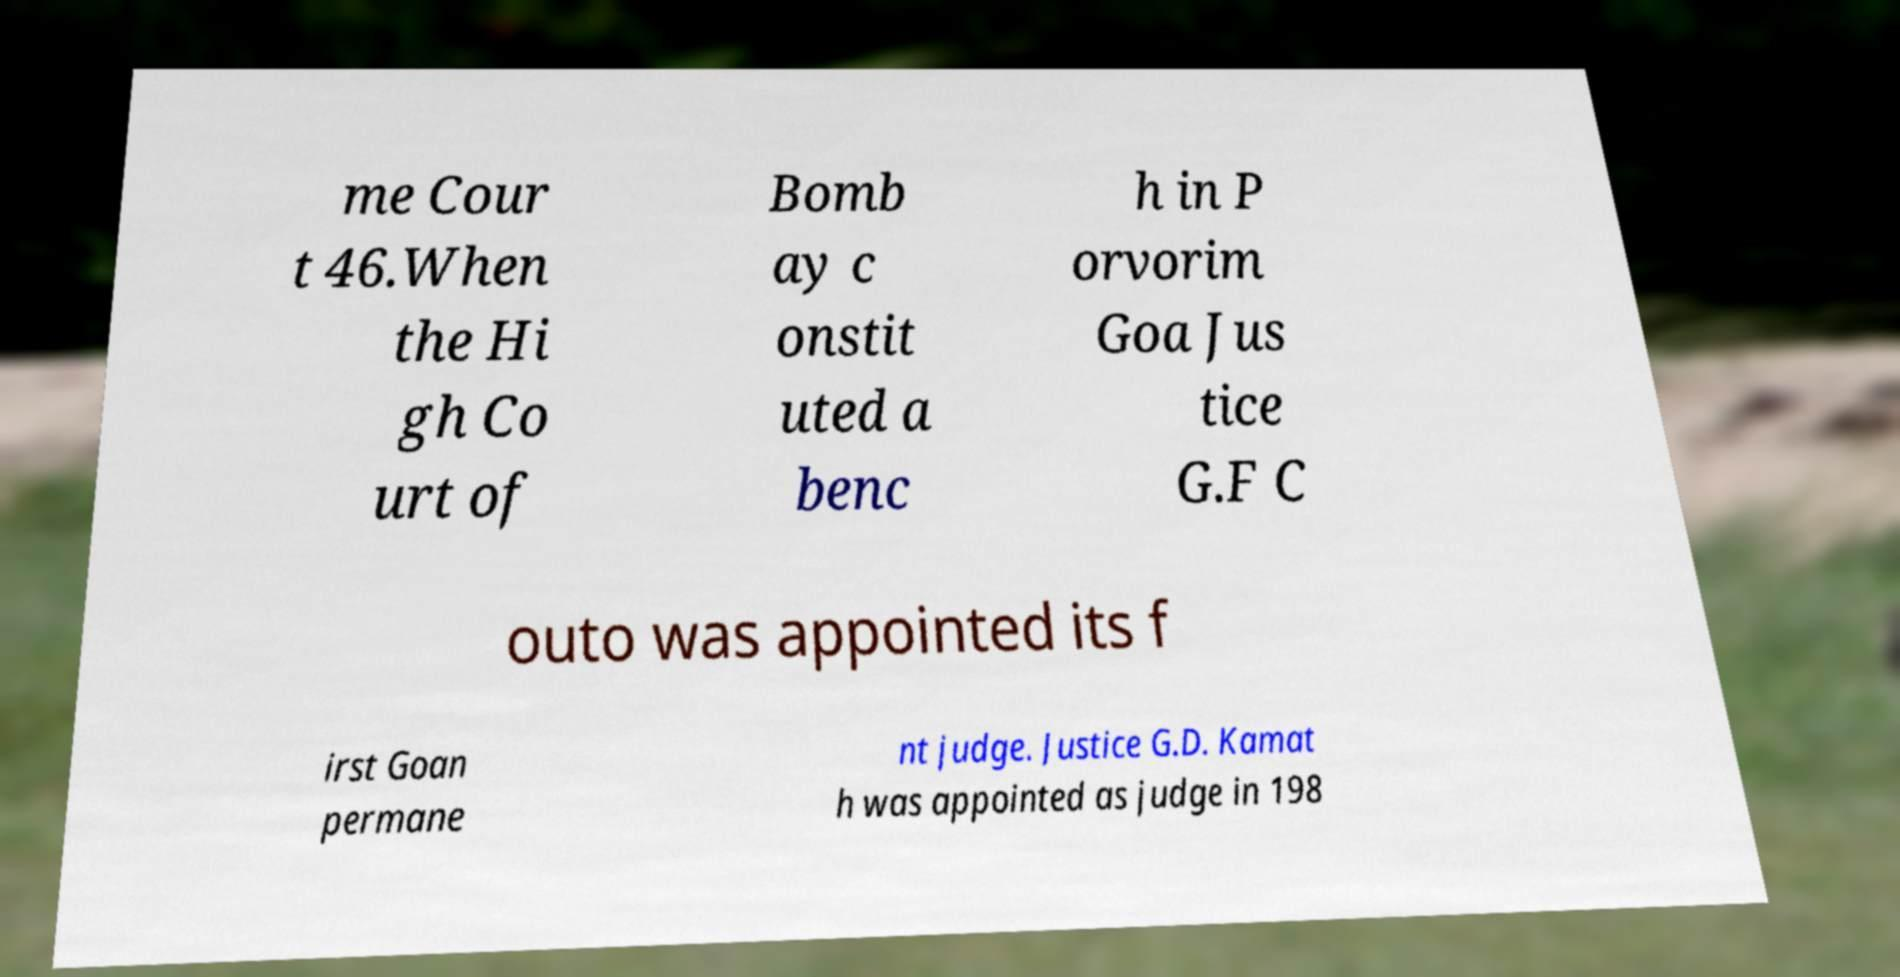Please read and relay the text visible in this image. What does it say? me Cour t 46.When the Hi gh Co urt of Bomb ay c onstit uted a benc h in P orvorim Goa Jus tice G.F C outo was appointed its f irst Goan permane nt judge. Justice G.D. Kamat h was appointed as judge in 198 